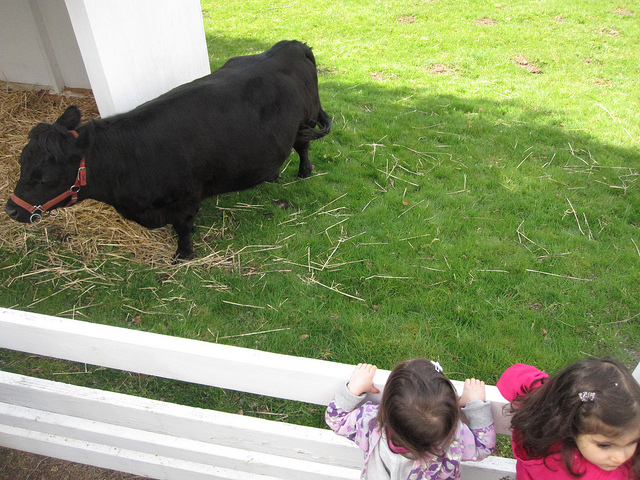<image>How old are the children? It is unknown how old the children are. How old are the children? I don't know how old the children are. They can be 2, toddlers, very young, or even young. 